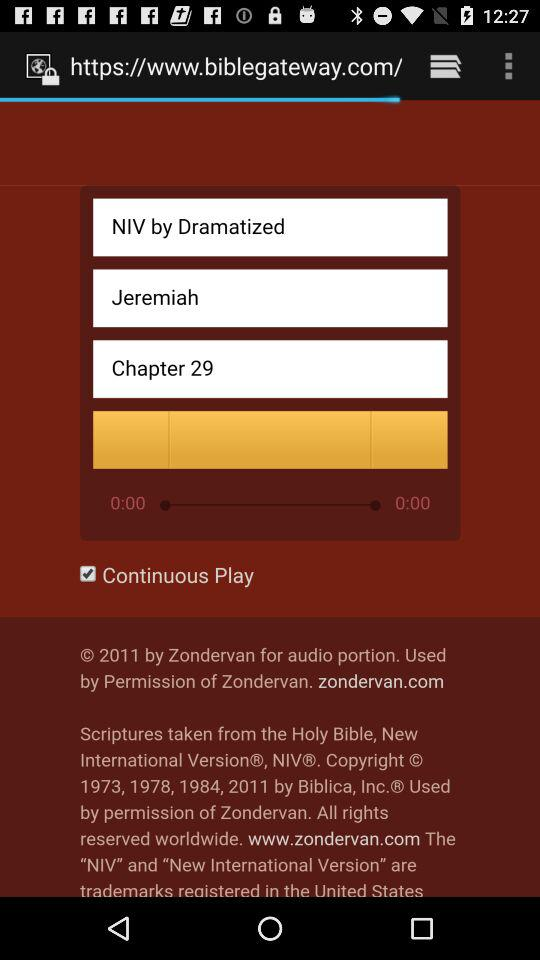What chapter is it? It is chapter 29. 